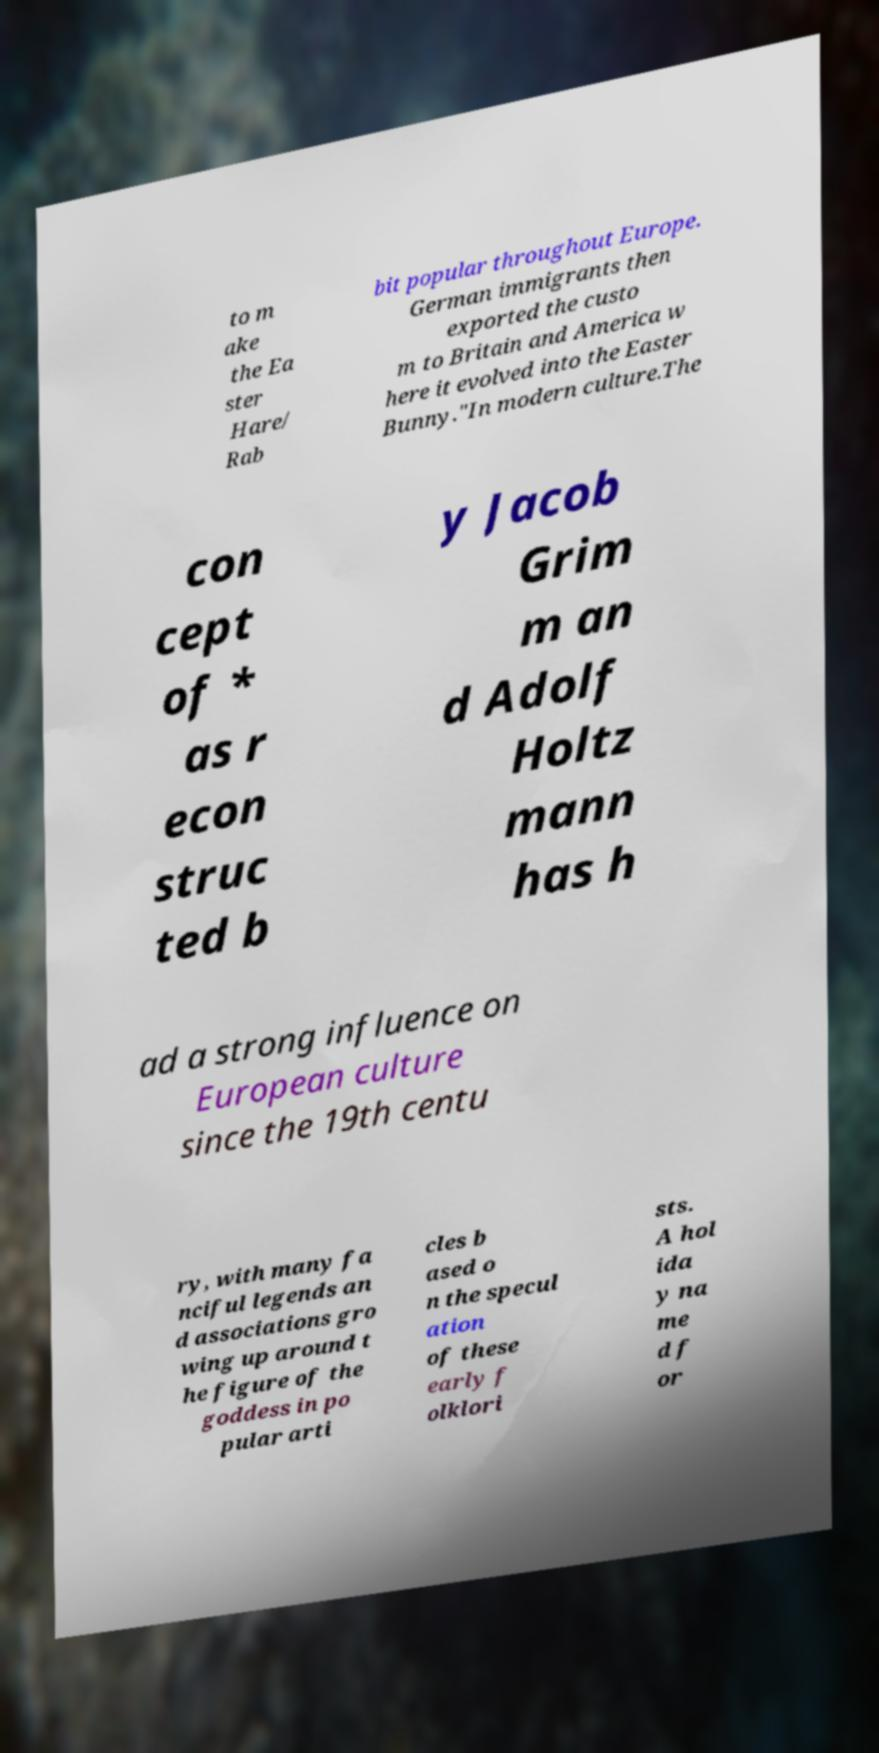Could you assist in decoding the text presented in this image and type it out clearly? to m ake the Ea ster Hare/ Rab bit popular throughout Europe. German immigrants then exported the custo m to Britain and America w here it evolved into the Easter Bunny."In modern culture.The con cept of * as r econ struc ted b y Jacob Grim m an d Adolf Holtz mann has h ad a strong influence on European culture since the 19th centu ry, with many fa nciful legends an d associations gro wing up around t he figure of the goddess in po pular arti cles b ased o n the specul ation of these early f olklori sts. A hol ida y na me d f or 